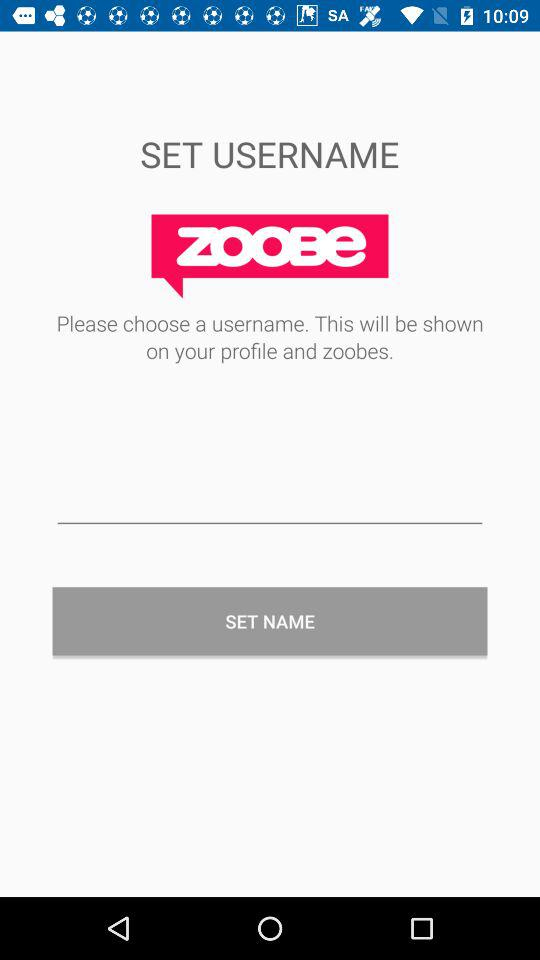What is the application name? The application name is "Zoobe". 